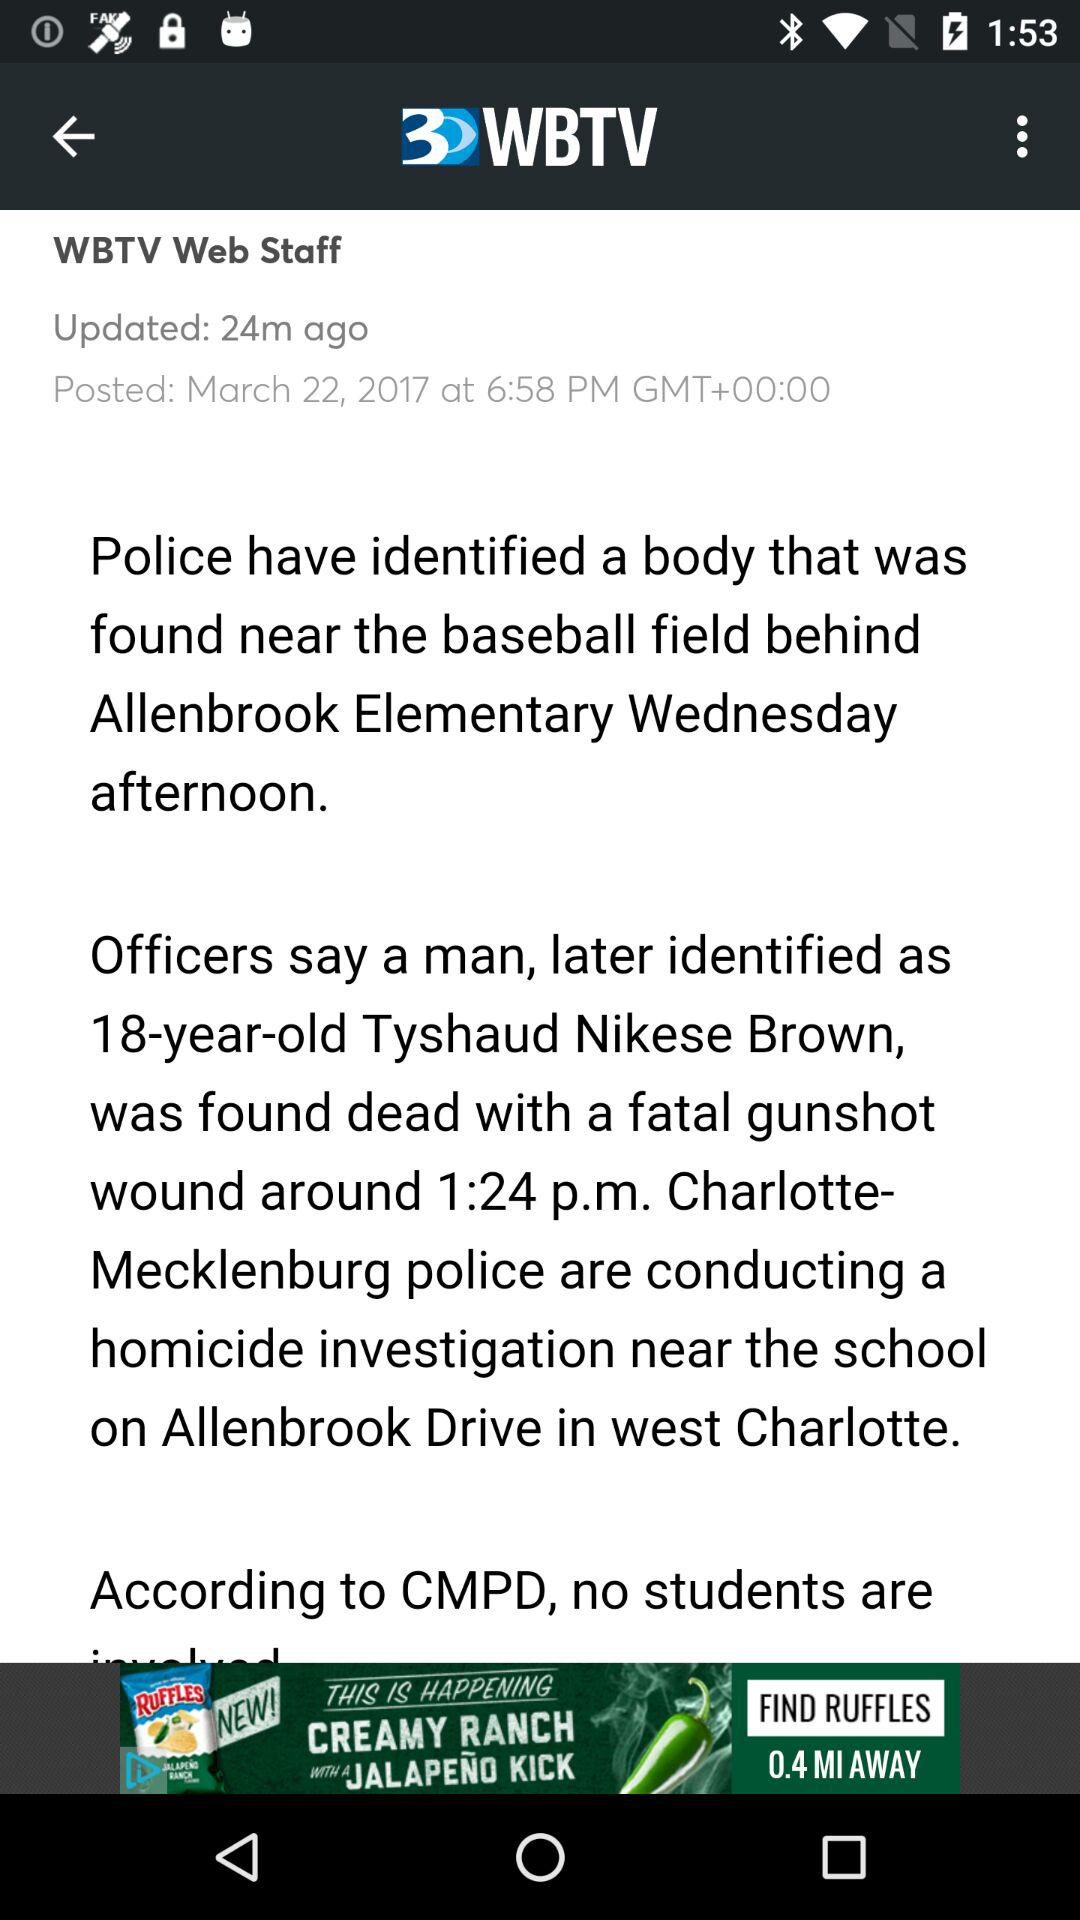Who was found dead? The person who was found dead was Tyshaud Nikese Brown. 